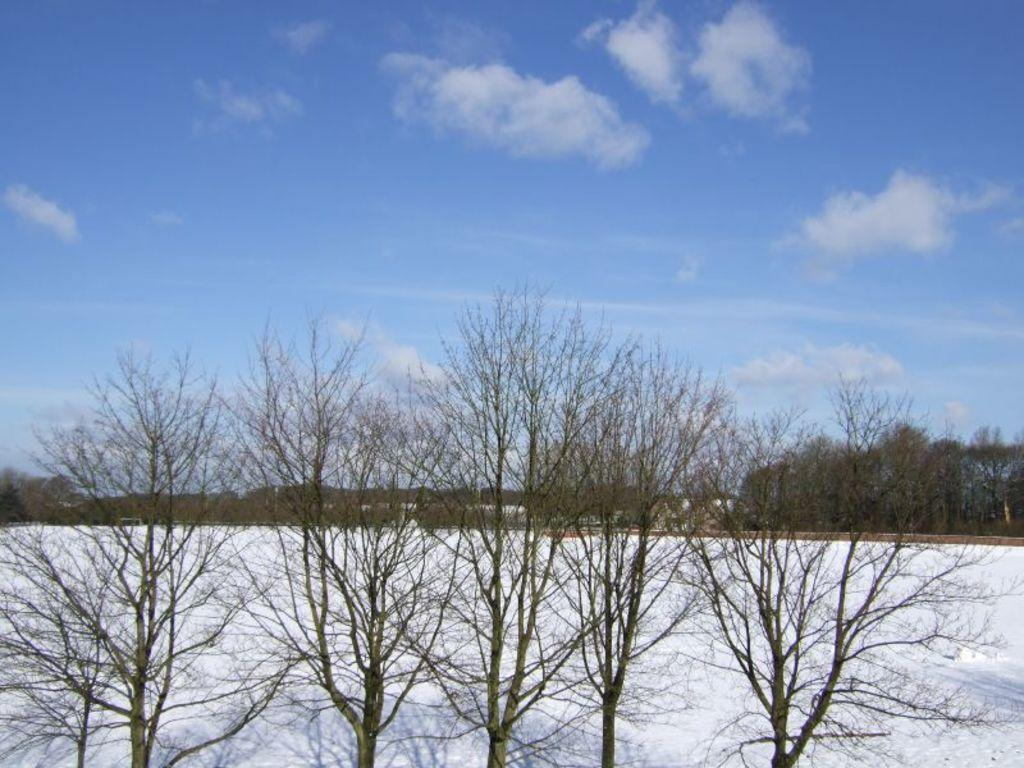What is located in the foreground of the image? There are trees in the foreground of the image. What is present at the bottom of the image? There is snow at the bottom of the image. What can be seen in the background of the image? There are trees in the background of the image. What is visible at the top of the image? The sky is visible at the top of the image. Where is the lock located in the image? There is no lock present in the image. What type of winter clothing is the woman wearing in the image? There is no woman present in the image. 